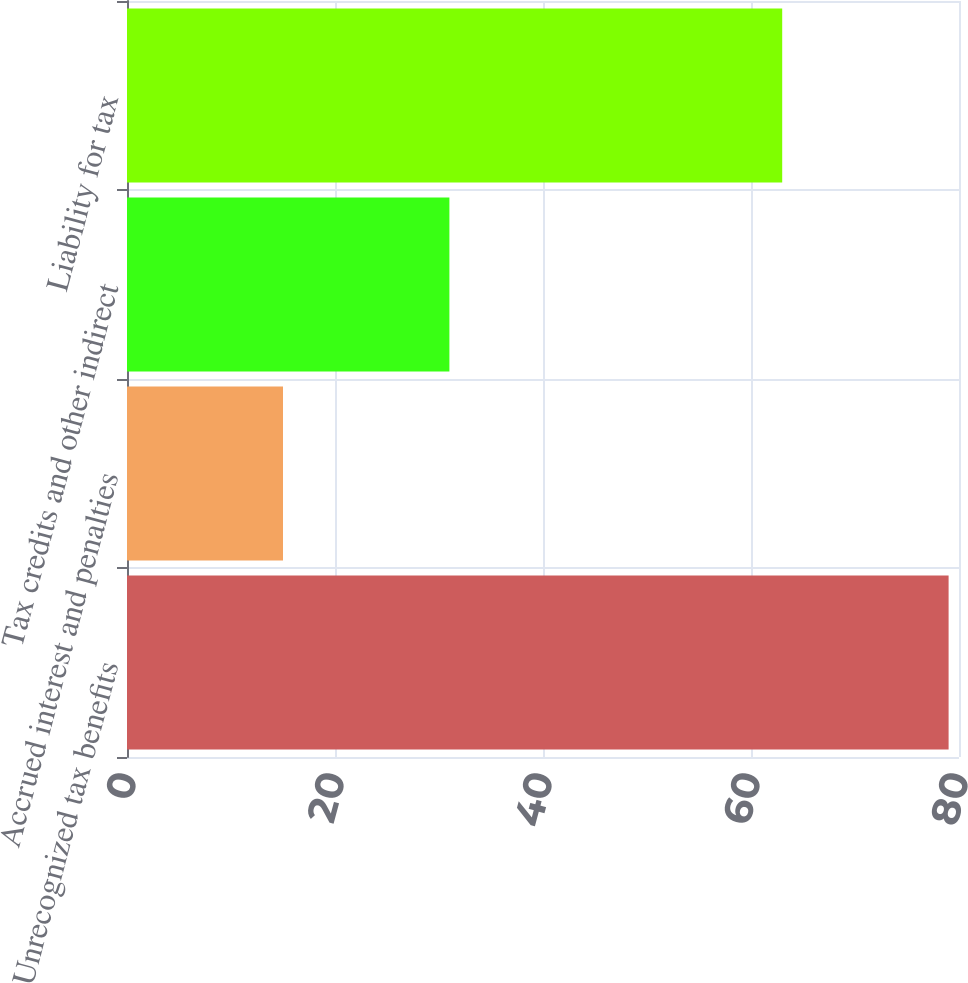Convert chart to OTSL. <chart><loc_0><loc_0><loc_500><loc_500><bar_chart><fcel>Unrecognized tax benefits<fcel>Accrued interest and penalties<fcel>Tax credits and other indirect<fcel>Liability for tax<nl><fcel>79<fcel>15<fcel>31<fcel>63<nl></chart> 